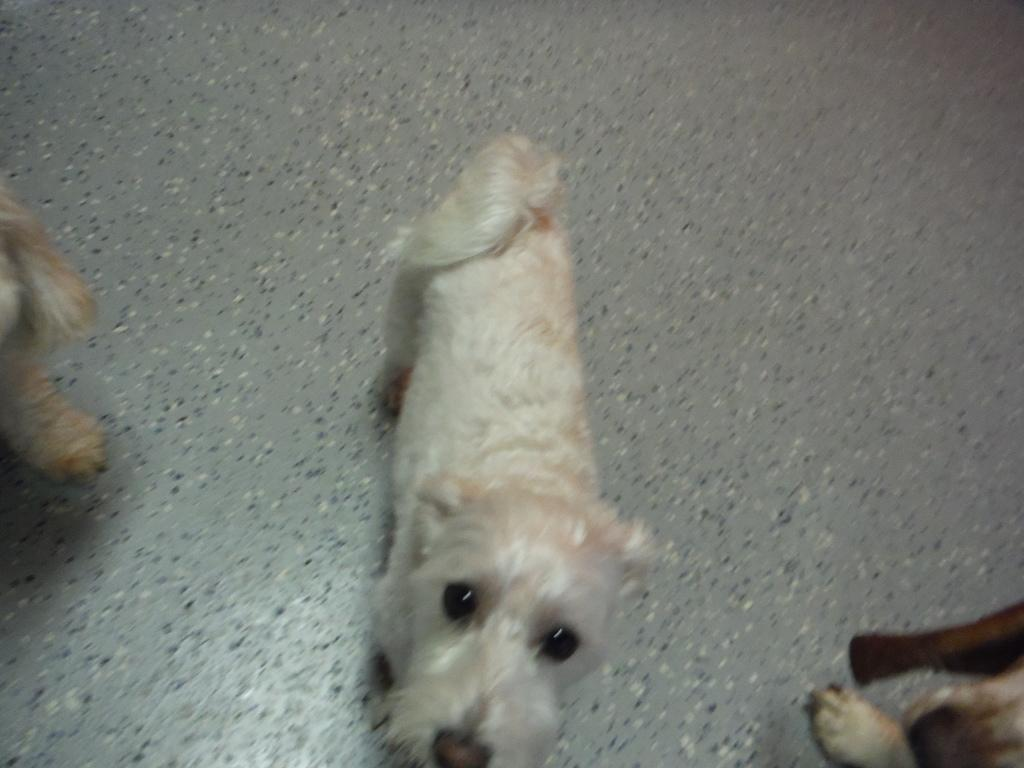How many dogs are present in the image? There are three dogs in the image. Can you describe the appearance of the dogs? The dogs are of different colors. Where are the dogs located in the image? The dogs are on the floor. What type of curve can be seen in the image? There is no curve present in the image; it features three dogs on the floor. How many giants are visible in the image? There are no giants present in the image; it features three dogs on the floor. 